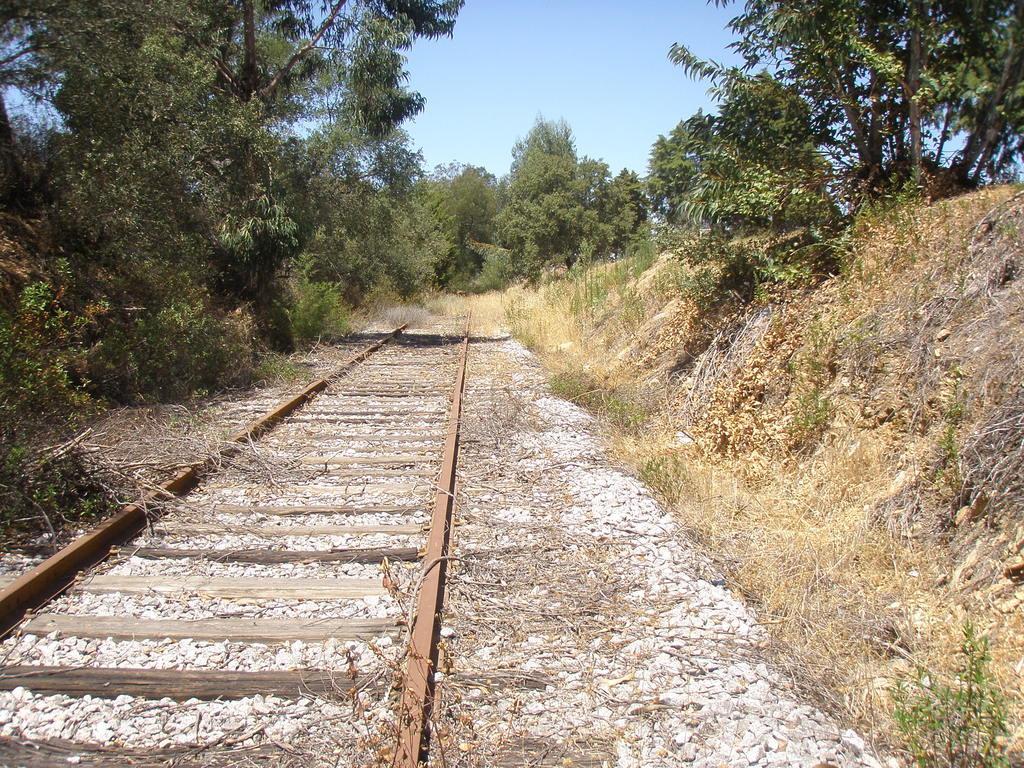In one or two sentences, can you explain what this image depicts? In this image in the front there is a railway track and there are stones. On the right side there is dry grass and there are trees. On the left side there are plants. In the background there are trees. 